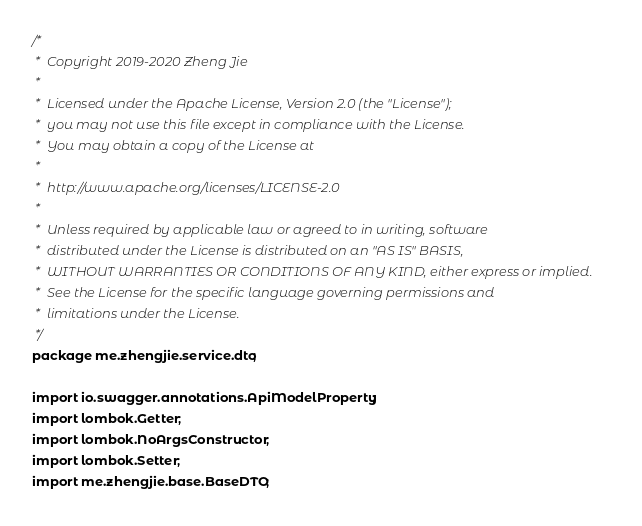<code> <loc_0><loc_0><loc_500><loc_500><_Java_>/*
 *  Copyright 2019-2020 Zheng Jie
 *
 *  Licensed under the Apache License, Version 2.0 (the "License");
 *  you may not use this file except in compliance with the License.
 *  You may obtain a copy of the License at
 *
 *  http://www.apache.org/licenses/LICENSE-2.0
 *
 *  Unless required by applicable law or agreed to in writing, software
 *  distributed under the License is distributed on an "AS IS" BASIS,
 *  WITHOUT WARRANTIES OR CONDITIONS OF ANY KIND, either express or implied.
 *  See the License for the specific language governing permissions and
 *  limitations under the License.
 */
package me.zhengjie.service.dto;

import io.swagger.annotations.ApiModelProperty;
import lombok.Getter;
import lombok.NoArgsConstructor;
import lombok.Setter;
import me.zhengjie.base.BaseDTO;</code> 